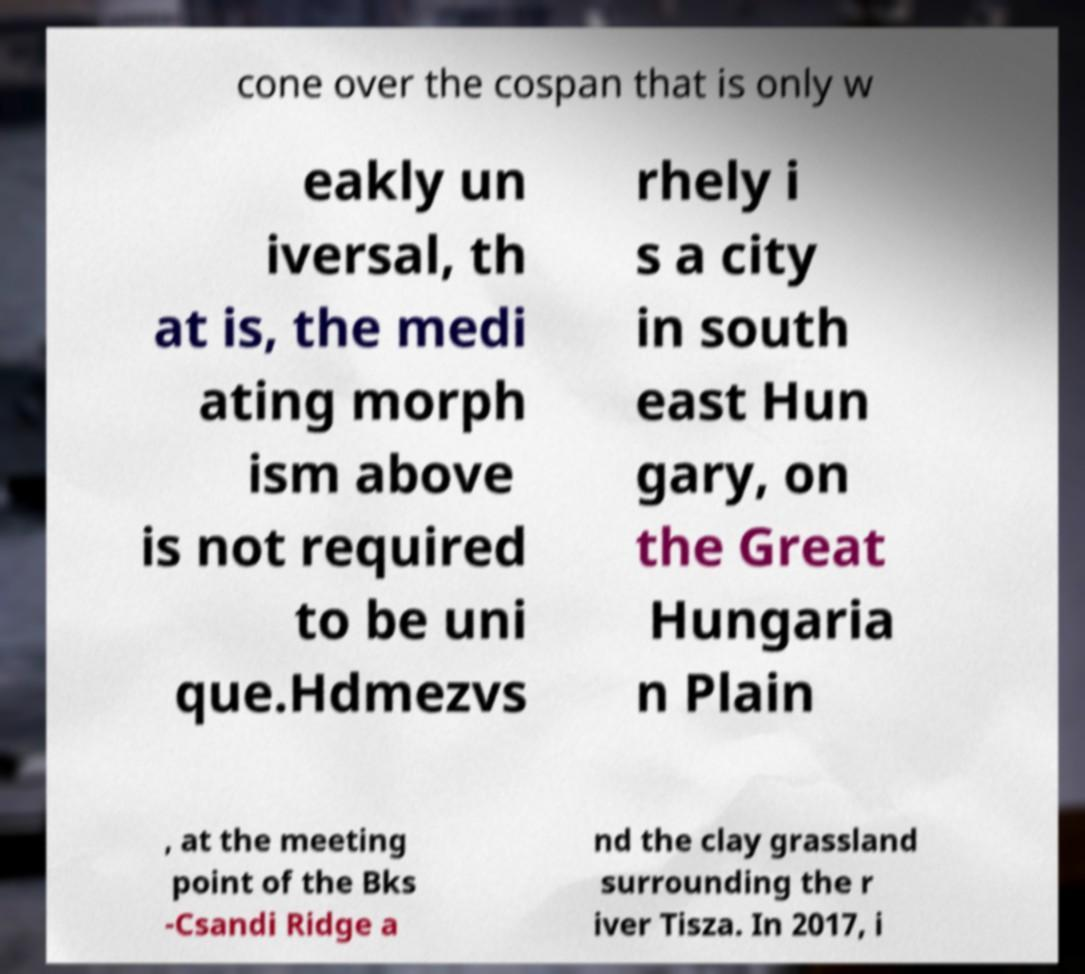Could you extract and type out the text from this image? cone over the cospan that is only w eakly un iversal, th at is, the medi ating morph ism above is not required to be uni que.Hdmezvs rhely i s a city in south east Hun gary, on the Great Hungaria n Plain , at the meeting point of the Bks -Csandi Ridge a nd the clay grassland surrounding the r iver Tisza. In 2017, i 